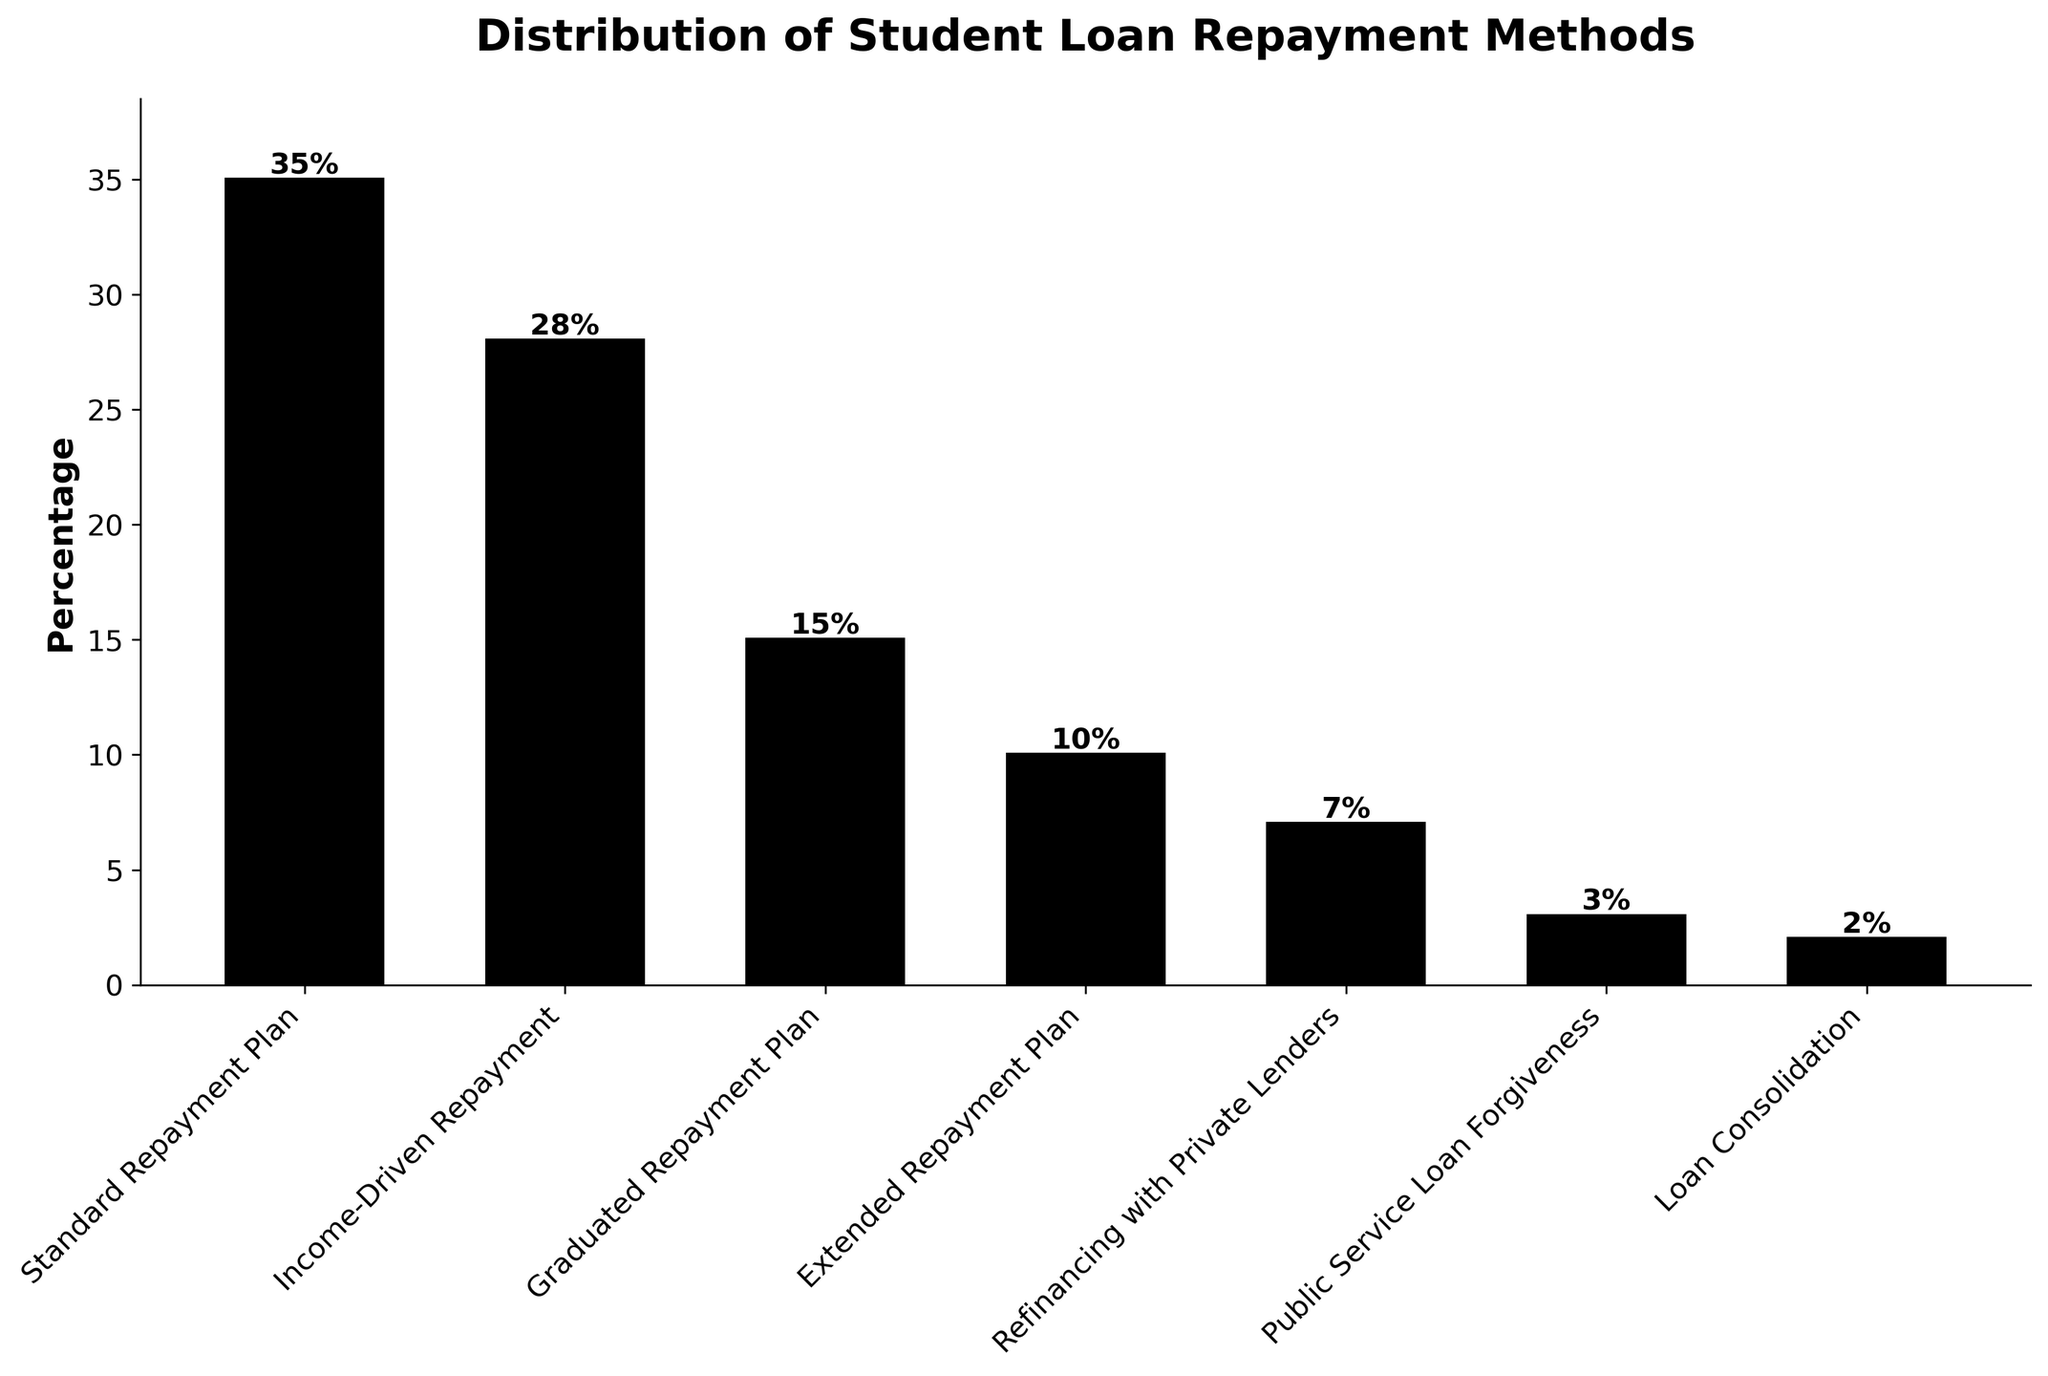What is the most common student loan repayment method? The most common repayment method can be identified by the highest bar in the chart. The "Standard Repayment Plan" has a bar reaching up to 35%.
Answer: Standard Repayment Plan Which repayment method has a slightly over one-fourth of the borrowers? By checking the percentage values, the "Income-Driven Repayment" method shows 28%, which is slightly over one-fourth of the total percentage.
Answer: Income-Driven Repayment How much higher is the percentage of borrowers using the Standard Repayment Plan than those using the Graduated Repayment Plan? The "Standard Repayment Plan" percentage is 35% and the "Graduated Repayment Plan" is 15%. The difference is calculated as 35% - 15% = 20%.
Answer: 20% Compare the usage of Income-Driven Repayment and Extended Repayment Plan. Which one is more popular and by how much? "Income-Driven Repayment" stands at 28%, while "Extended Repayment Plan" is at 10%. To determine which is more popular: 28% - 10% = 18%, indicating the Income-Driven Repayment is more popular by 18%.
Answer: Income-Driven Repayment, 18% What is the total percentage of borrowers who are using either the Standard Repayment Plan or the Income-Driven Repayment method? Adding the percentages for "Standard Repayment Plan" and "Income-Driven Repayment": 35% + 28% = 63%.
Answer: 63% How does the height of the bar representing Loan Consolidation compare to the bar representing Public Service Loan Forgiveness? "Loan Consolidation" stands at 2%, while "Public Service Loan Forgiveness" is at 3%. The comparison can be observed by their respective heights, with the latter slightly taller.
Answer: Public Service Loan Forgiveness is taller by 1% What fraction of borrowers use either the Graduated Repayment Plan, Extended Repayment Plan, or Refinancing with Private Lenders? Adding the percentages for these three methods: 15% (Graduated) + 10% (Extended) + 7% (Refinancing) = 32%.
Answer: 32% If we combine the percentages of those using Public Service Loan Forgiveness and Loan Consolidation, how does it compare to the percentage of borrowers using Refinancing with Private Lenders? Combining the percentages: 3% (Public Service) + 2% (Loan Consolidation) = 5%, Refinancing has 7%. The combined percentage is 2% less than the Refinancing percentage.
Answer: 2% less What is the least popular repayment method and its corresponding percentage? The smallest bar represents the least popular method. "Loan Consolidation" has the smallest percentage at 2%.
Answer: Loan Consolidation, 2% Which repayment methods have a percentage equal to or greater than 10%? The bars representing percentages equal to or greater than 10% include: "Standard Repayment Plan" (35%), "Income-Driven Repayment" (28%), "Graduated Repayment Plan" (15%), and "Extended Repayment Plan" (10%).
Answer: Standard Repayment Plan, Income-Driven Repayment, Graduated Repayment Plan, Extended Repayment Plan 